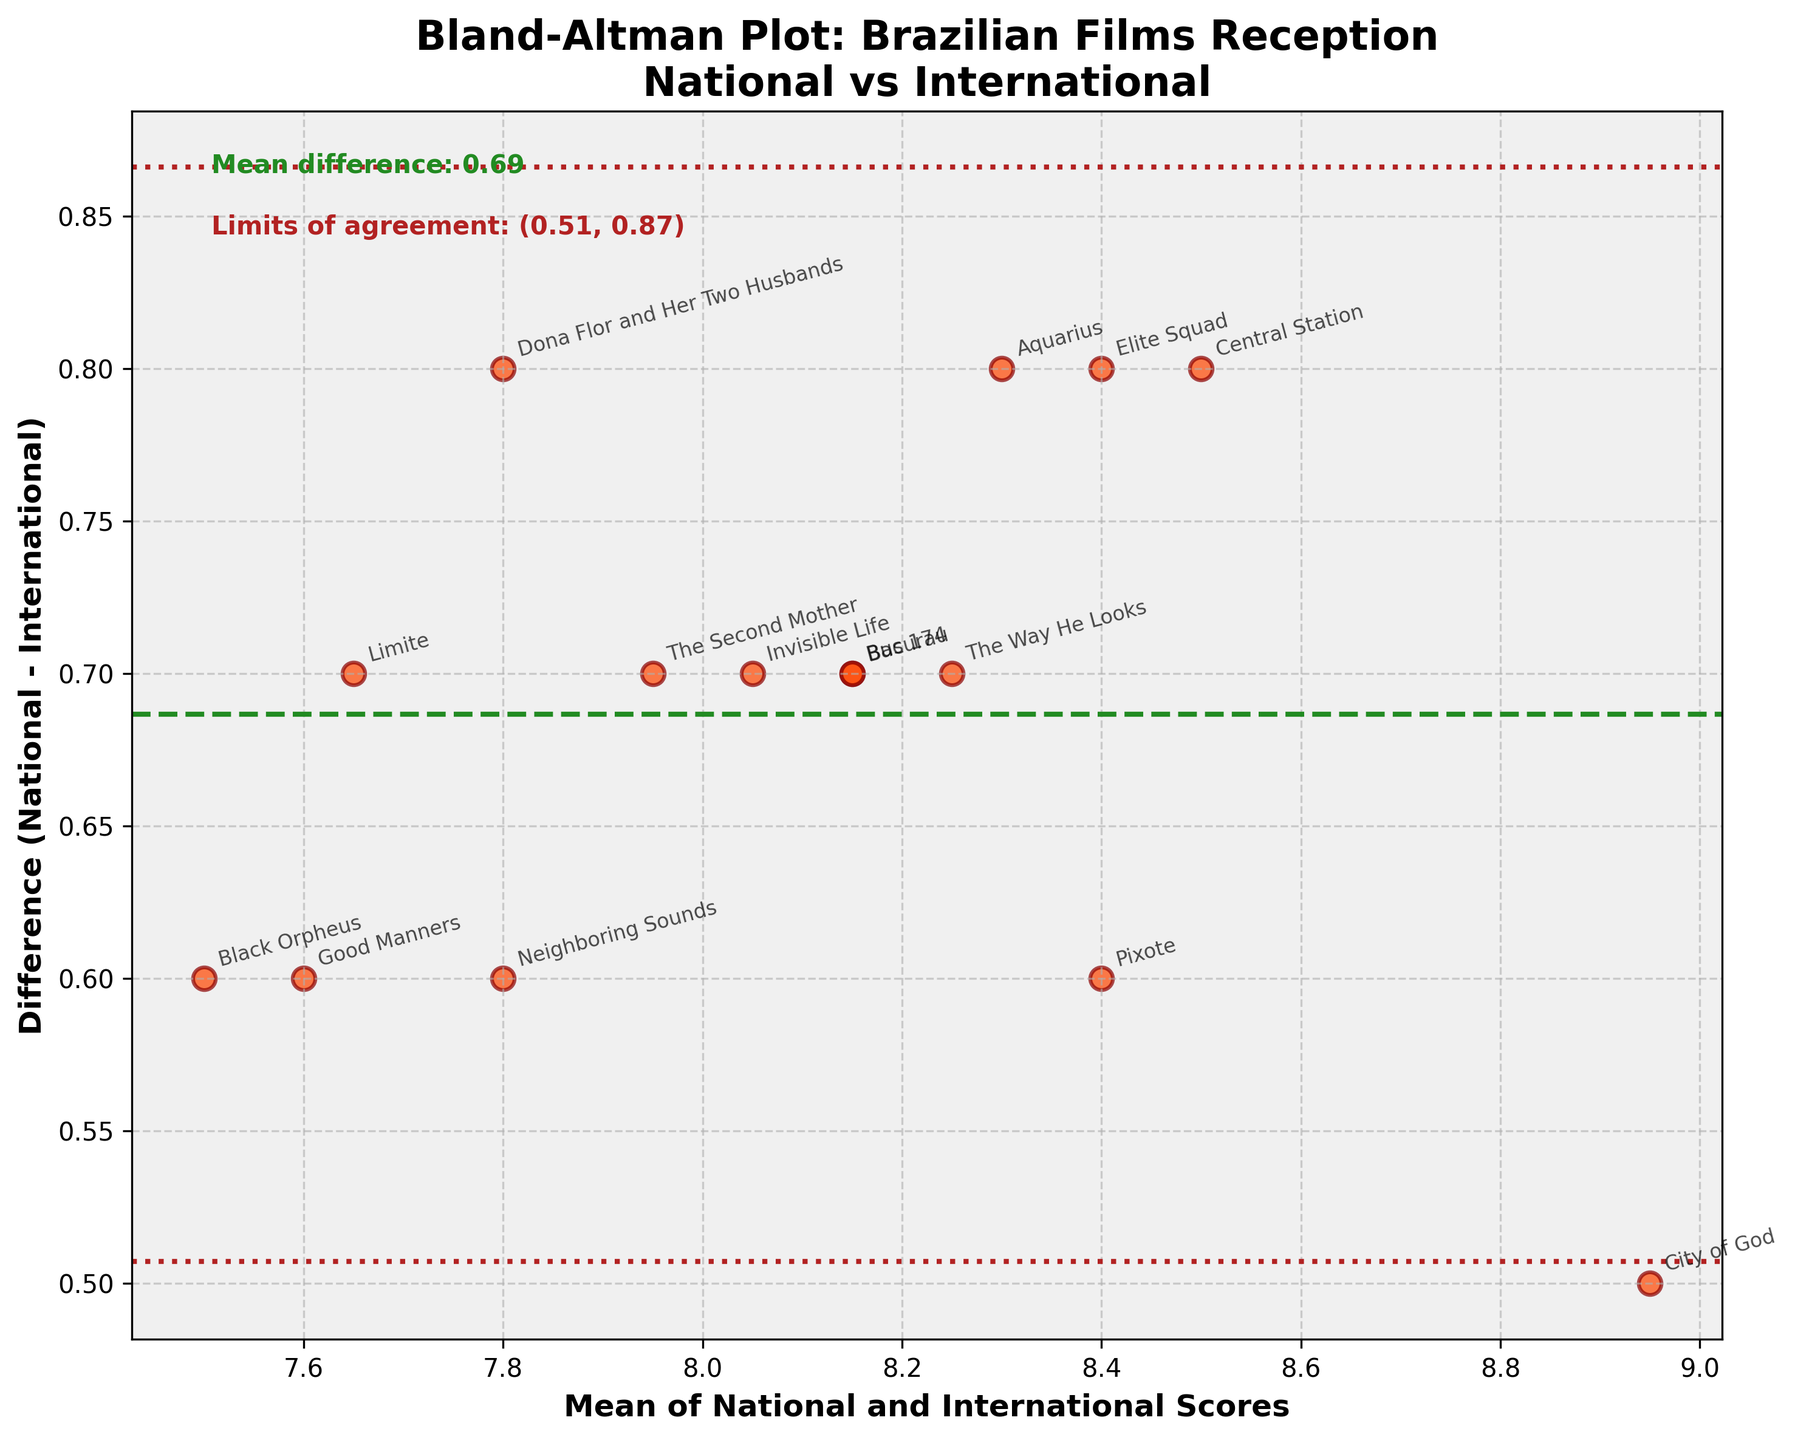What's the main title of the plot? The title is positioned prominently above the plot and reads, "Bland-Altman Plot: Brazilian Films Reception\nNational vs International".
Answer: Bland-Altman Plot: Brazilian Films Reception\nNational vs International How many films are compared in this plot? Each point on the plot represents a film, so counting the points can determine the number of films. There are 15 points on the plot.
Answer: 15 What's the mean difference between the national scores and international scores? The mean difference is annotated on the plot. It is noted as "Mean difference: 0.70".
Answer: 0.70 What are the limits of agreement shown in the plot? The limits of agreement are also annotated on the plot and read "Limits of agreement: (0.15, 1.25)".
Answer: (0.15, 1.25) Which axis represents the difference between national and international scores? The y-axis, labeled "Difference (National - International)", shows the difference between the scores.
Answer: y-axis Which film has the smallest difference between national and international scores? By finding the point closest to the x-axis (y-value nearly 0), "City of God" has the smallest difference.
Answer: City of God Are most of the film points above or below the mean difference line? Observing the plot, most points (11 out of 15) lie above the mean difference line.
Answer: Above What is the highest mean score and which film does it correspond to? The highest mean score point is near 9.05 on the x-axis, corresponding to "City of God".
Answer: City of God How does the Mean of National and International Scores axis range? The x-axis ranges from approximately 7.5 to 9.0, based on the spread of points.
Answer: ~7.5 to 9.0 Which film has the largest negative difference between national and international scores? The point with the lowest y-value is the furthest below the x-axis, corresponding to "Black Orpheus".
Answer: Black Orpheus 